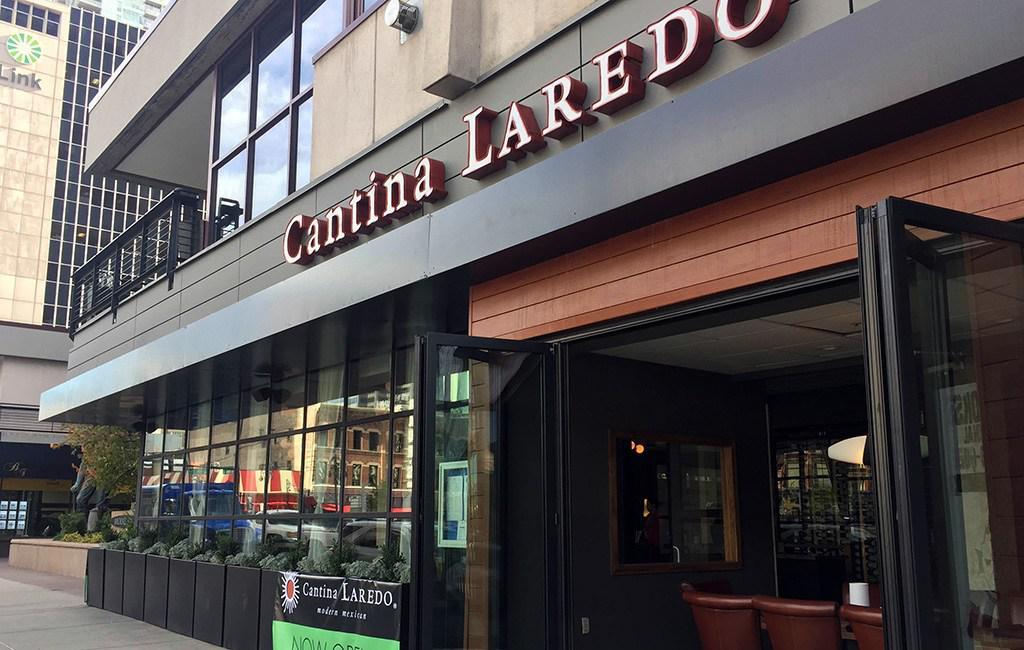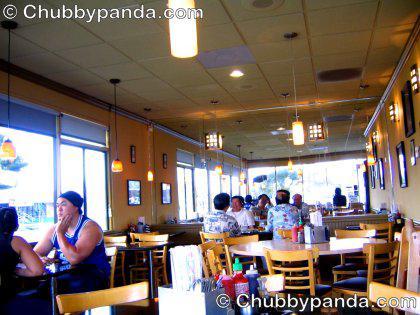The first image is the image on the left, the second image is the image on the right. For the images shown, is this caption "One of the restaurants has several customers sitting in chairs." true? Answer yes or no. Yes. The first image is the image on the left, the second image is the image on the right. For the images displayed, is the sentence "There are two cafes with internal views." factually correct? Answer yes or no. No. 